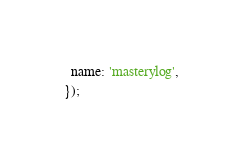<code> <loc_0><loc_0><loc_500><loc_500><_JavaScript_>  name: 'masterylog',
});
</code> 